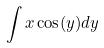<formula> <loc_0><loc_0><loc_500><loc_500>\int x \cos ( y ) d y</formula> 